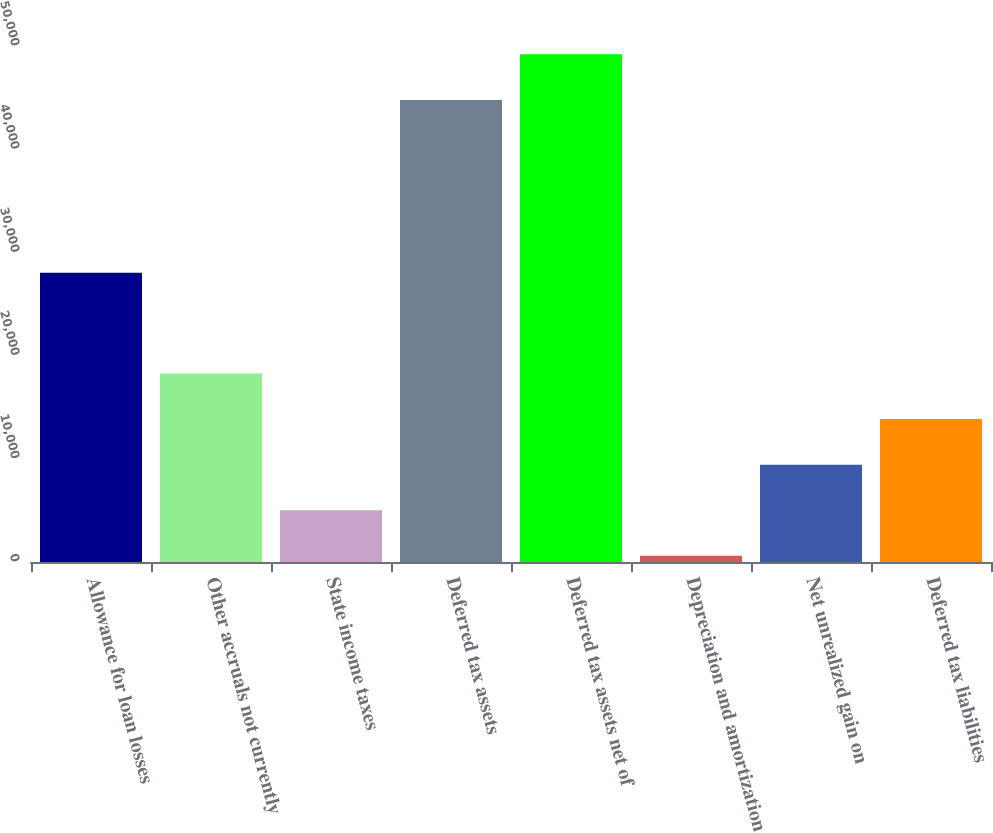Convert chart. <chart><loc_0><loc_0><loc_500><loc_500><bar_chart><fcel>Allowance for loan losses<fcel>Other accruals not currently<fcel>State income taxes<fcel>Deferred tax assets<fcel>Deferred tax assets net of<fcel>Depreciation and amortization<fcel>Net unrealized gain on<fcel>Deferred tax liabilities<nl><fcel>28023<fcel>18269.6<fcel>5017.4<fcel>44774<fcel>49191.4<fcel>600<fcel>9434.8<fcel>13852.2<nl></chart> 